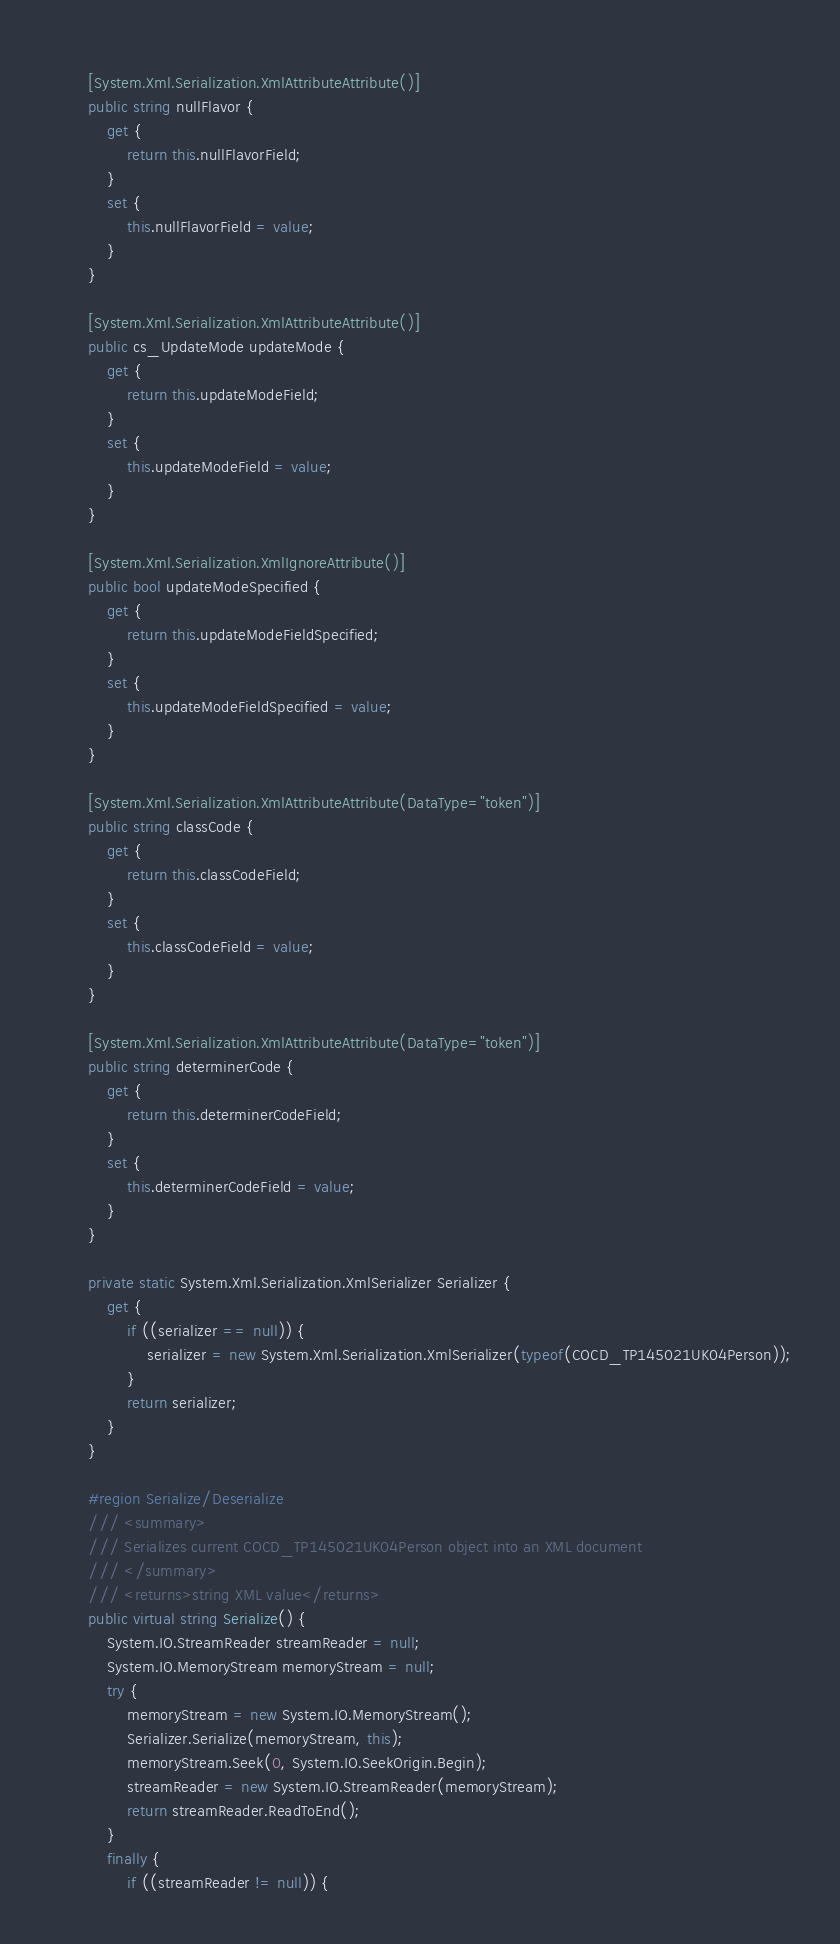Convert code to text. <code><loc_0><loc_0><loc_500><loc_500><_C#_>        
        [System.Xml.Serialization.XmlAttributeAttribute()]
        public string nullFlavor {
            get {
                return this.nullFlavorField;
            }
            set {
                this.nullFlavorField = value;
            }
        }
        
        [System.Xml.Serialization.XmlAttributeAttribute()]
        public cs_UpdateMode updateMode {
            get {
                return this.updateModeField;
            }
            set {
                this.updateModeField = value;
            }
        }
        
        [System.Xml.Serialization.XmlIgnoreAttribute()]
        public bool updateModeSpecified {
            get {
                return this.updateModeFieldSpecified;
            }
            set {
                this.updateModeFieldSpecified = value;
            }
        }
        
        [System.Xml.Serialization.XmlAttributeAttribute(DataType="token")]
        public string classCode {
            get {
                return this.classCodeField;
            }
            set {
                this.classCodeField = value;
            }
        }
        
        [System.Xml.Serialization.XmlAttributeAttribute(DataType="token")]
        public string determinerCode {
            get {
                return this.determinerCodeField;
            }
            set {
                this.determinerCodeField = value;
            }
        }
        
        private static System.Xml.Serialization.XmlSerializer Serializer {
            get {
                if ((serializer == null)) {
                    serializer = new System.Xml.Serialization.XmlSerializer(typeof(COCD_TP145021UK04Person));
                }
                return serializer;
            }
        }
        
        #region Serialize/Deserialize
        /// <summary>
        /// Serializes current COCD_TP145021UK04Person object into an XML document
        /// </summary>
        /// <returns>string XML value</returns>
        public virtual string Serialize() {
            System.IO.StreamReader streamReader = null;
            System.IO.MemoryStream memoryStream = null;
            try {
                memoryStream = new System.IO.MemoryStream();
                Serializer.Serialize(memoryStream, this);
                memoryStream.Seek(0, System.IO.SeekOrigin.Begin);
                streamReader = new System.IO.StreamReader(memoryStream);
                return streamReader.ReadToEnd();
            }
            finally {
                if ((streamReader != null)) {</code> 